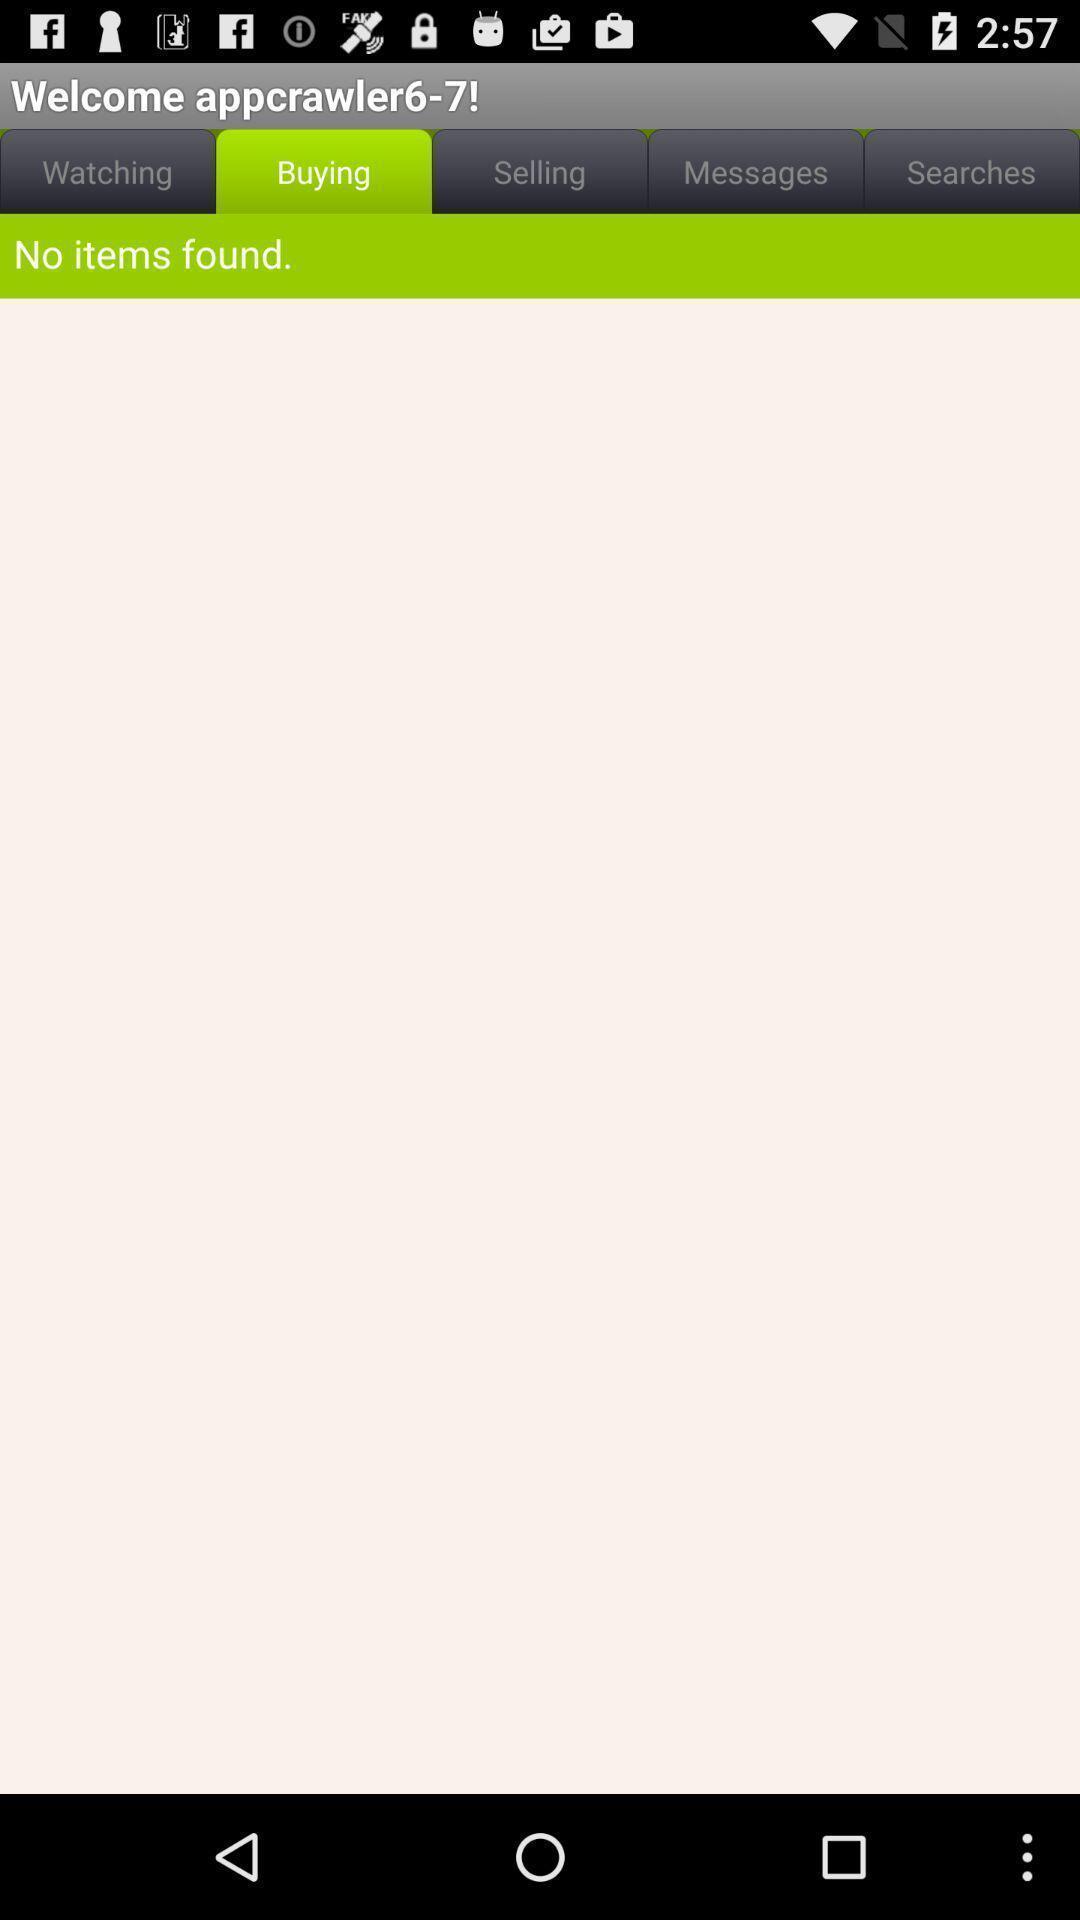Summarize the main components in this picture. Welcome page of a shopping app. 